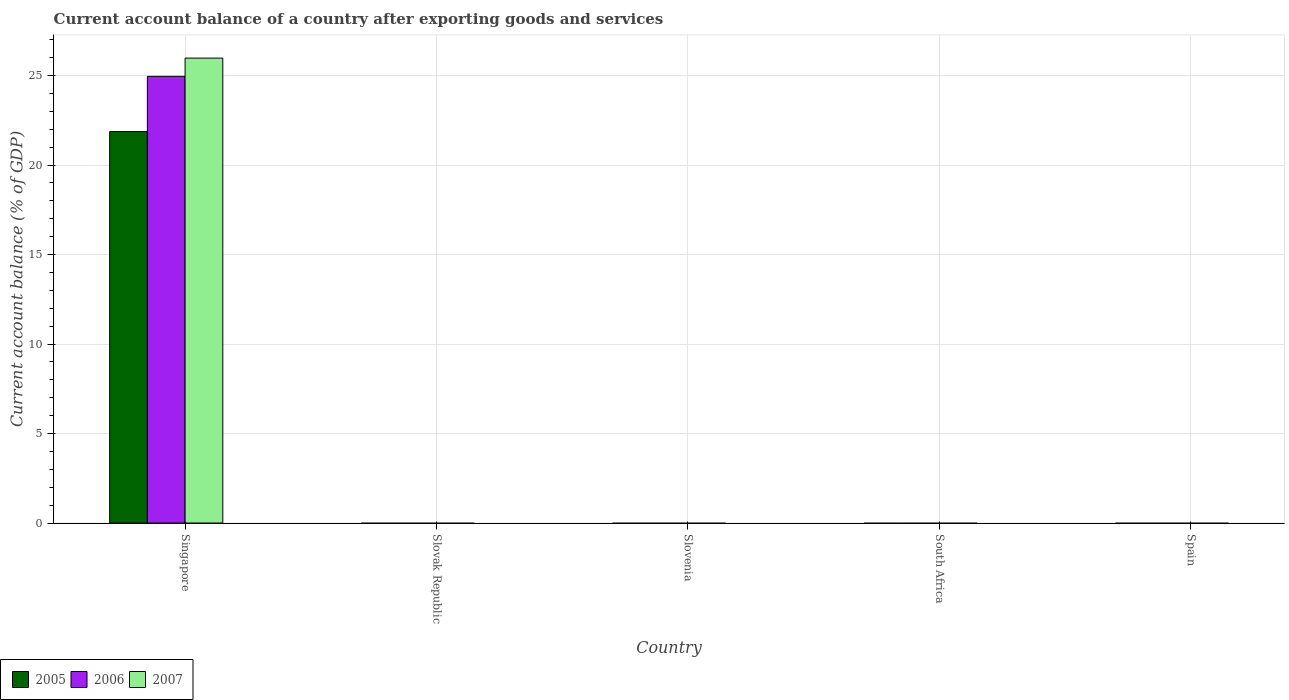Are the number of bars on each tick of the X-axis equal?
Your answer should be compact. No. How many bars are there on the 2nd tick from the left?
Provide a succinct answer. 0. How many bars are there on the 2nd tick from the right?
Offer a very short reply. 0. What is the label of the 4th group of bars from the left?
Ensure brevity in your answer.  South Africa. What is the account balance in 2007 in South Africa?
Give a very brief answer. 0. Across all countries, what is the maximum account balance in 2007?
Offer a terse response. 25.97. In which country was the account balance in 2006 maximum?
Give a very brief answer. Singapore. What is the total account balance in 2005 in the graph?
Offer a very short reply. 21.87. What is the difference between the account balance in 2005 in Singapore and the account balance in 2007 in Slovak Republic?
Make the answer very short. 21.87. What is the average account balance in 2007 per country?
Your response must be concise. 5.19. What is the difference between the account balance of/in 2007 and account balance of/in 2005 in Singapore?
Your answer should be very brief. 4.1. What is the difference between the highest and the lowest account balance in 2007?
Ensure brevity in your answer.  25.97. In how many countries, is the account balance in 2005 greater than the average account balance in 2005 taken over all countries?
Provide a short and direct response. 1. How many countries are there in the graph?
Provide a succinct answer. 5. Are the values on the major ticks of Y-axis written in scientific E-notation?
Your response must be concise. No. How are the legend labels stacked?
Your answer should be very brief. Horizontal. What is the title of the graph?
Your answer should be very brief. Current account balance of a country after exporting goods and services. What is the label or title of the X-axis?
Keep it short and to the point. Country. What is the label or title of the Y-axis?
Provide a short and direct response. Current account balance (% of GDP). What is the Current account balance (% of GDP) in 2005 in Singapore?
Offer a very short reply. 21.87. What is the Current account balance (% of GDP) in 2006 in Singapore?
Your response must be concise. 24.96. What is the Current account balance (% of GDP) in 2007 in Singapore?
Provide a succinct answer. 25.97. What is the Current account balance (% of GDP) of 2005 in Slovenia?
Ensure brevity in your answer.  0. What is the Current account balance (% of GDP) of 2007 in Slovenia?
Keep it short and to the point. 0. What is the Current account balance (% of GDP) of 2005 in South Africa?
Give a very brief answer. 0. Across all countries, what is the maximum Current account balance (% of GDP) in 2005?
Your response must be concise. 21.87. Across all countries, what is the maximum Current account balance (% of GDP) in 2006?
Your answer should be very brief. 24.96. Across all countries, what is the maximum Current account balance (% of GDP) in 2007?
Your response must be concise. 25.97. Across all countries, what is the minimum Current account balance (% of GDP) of 2006?
Your answer should be very brief. 0. Across all countries, what is the minimum Current account balance (% of GDP) in 2007?
Provide a succinct answer. 0. What is the total Current account balance (% of GDP) in 2005 in the graph?
Offer a very short reply. 21.87. What is the total Current account balance (% of GDP) in 2006 in the graph?
Ensure brevity in your answer.  24.96. What is the total Current account balance (% of GDP) in 2007 in the graph?
Ensure brevity in your answer.  25.97. What is the average Current account balance (% of GDP) of 2005 per country?
Offer a very short reply. 4.37. What is the average Current account balance (% of GDP) of 2006 per country?
Keep it short and to the point. 4.99. What is the average Current account balance (% of GDP) in 2007 per country?
Ensure brevity in your answer.  5.19. What is the difference between the Current account balance (% of GDP) in 2005 and Current account balance (% of GDP) in 2006 in Singapore?
Your answer should be compact. -3.08. What is the difference between the Current account balance (% of GDP) in 2005 and Current account balance (% of GDP) in 2007 in Singapore?
Provide a succinct answer. -4.1. What is the difference between the Current account balance (% of GDP) of 2006 and Current account balance (% of GDP) of 2007 in Singapore?
Ensure brevity in your answer.  -1.02. What is the difference between the highest and the lowest Current account balance (% of GDP) in 2005?
Offer a very short reply. 21.87. What is the difference between the highest and the lowest Current account balance (% of GDP) of 2006?
Make the answer very short. 24.96. What is the difference between the highest and the lowest Current account balance (% of GDP) of 2007?
Provide a succinct answer. 25.97. 